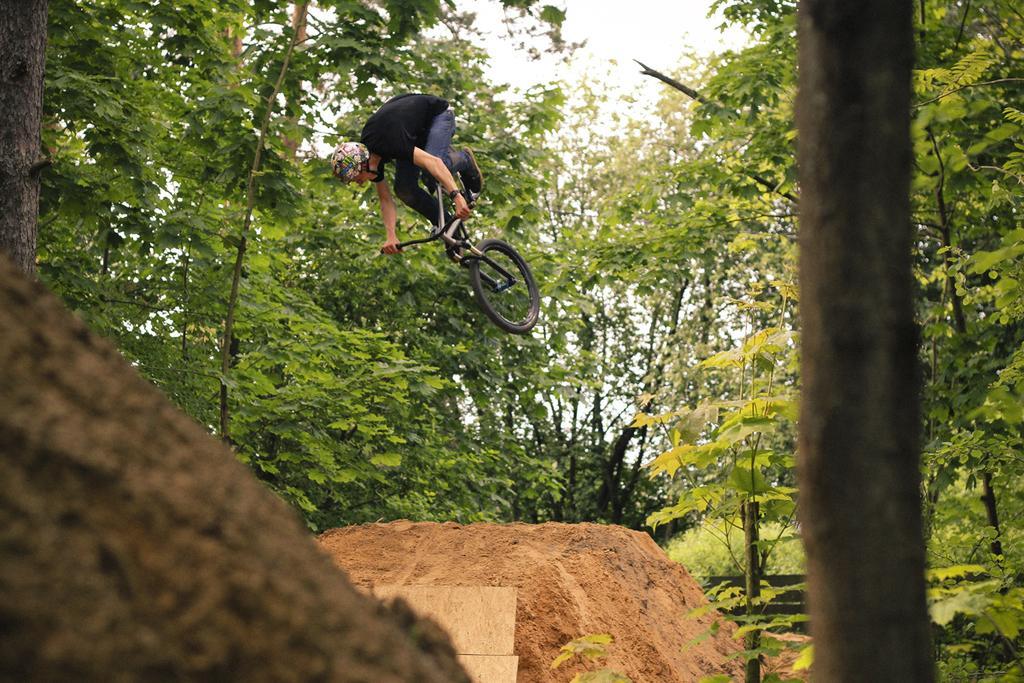In one or two sentences, can you explain what this image depicts? In this image I can see a person flying in the air with the bicycle. In the ground there is a mud. At the back there are some trees and the sky. 